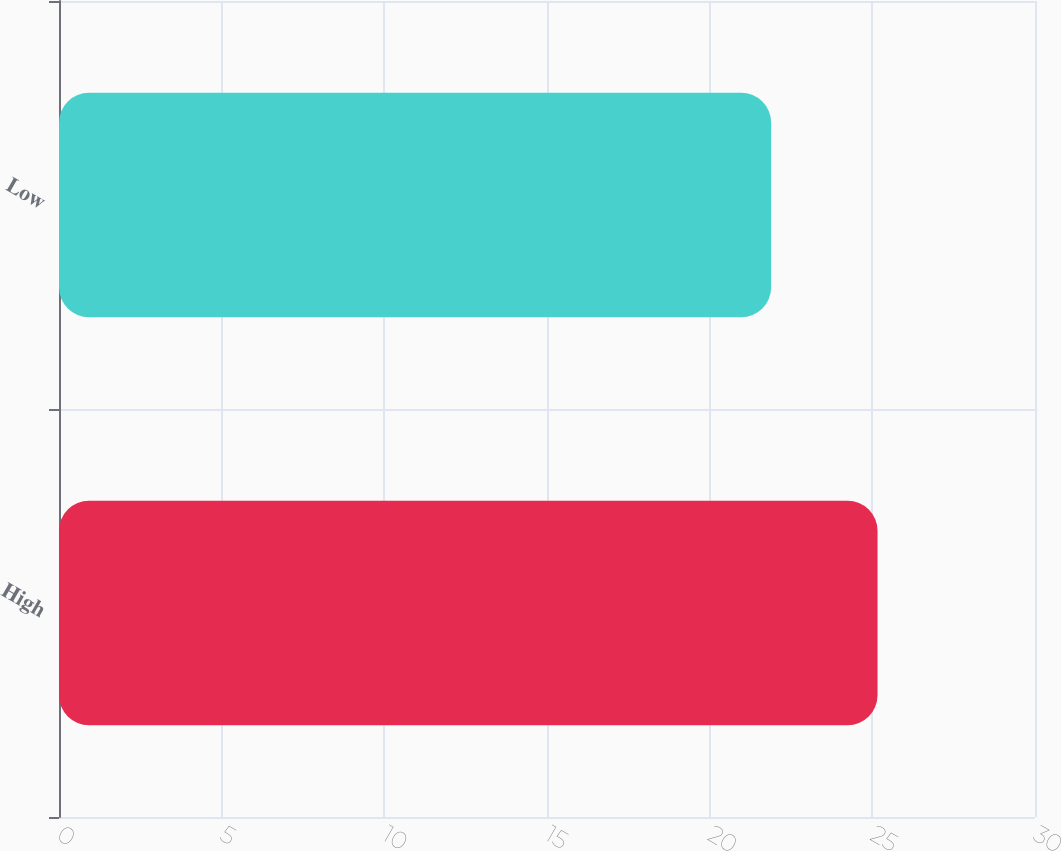Convert chart to OTSL. <chart><loc_0><loc_0><loc_500><loc_500><bar_chart><fcel>High<fcel>Low<nl><fcel>25.16<fcel>21.89<nl></chart> 